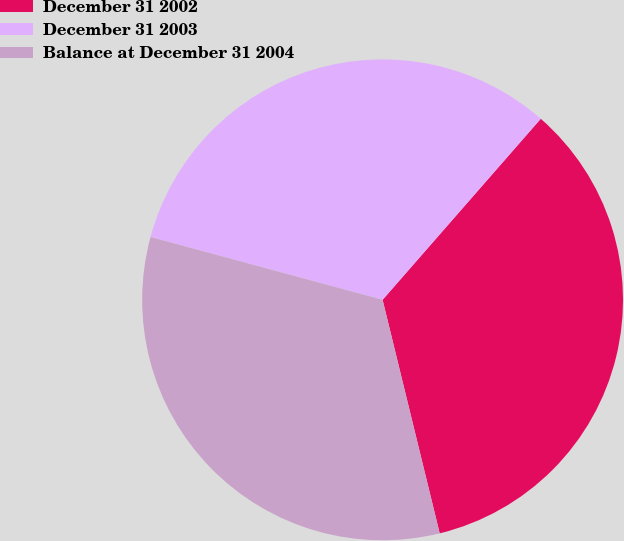<chart> <loc_0><loc_0><loc_500><loc_500><pie_chart><fcel>December 31 2002<fcel>December 31 2003<fcel>Balance at December 31 2004<nl><fcel>34.75%<fcel>32.22%<fcel>33.02%<nl></chart> 